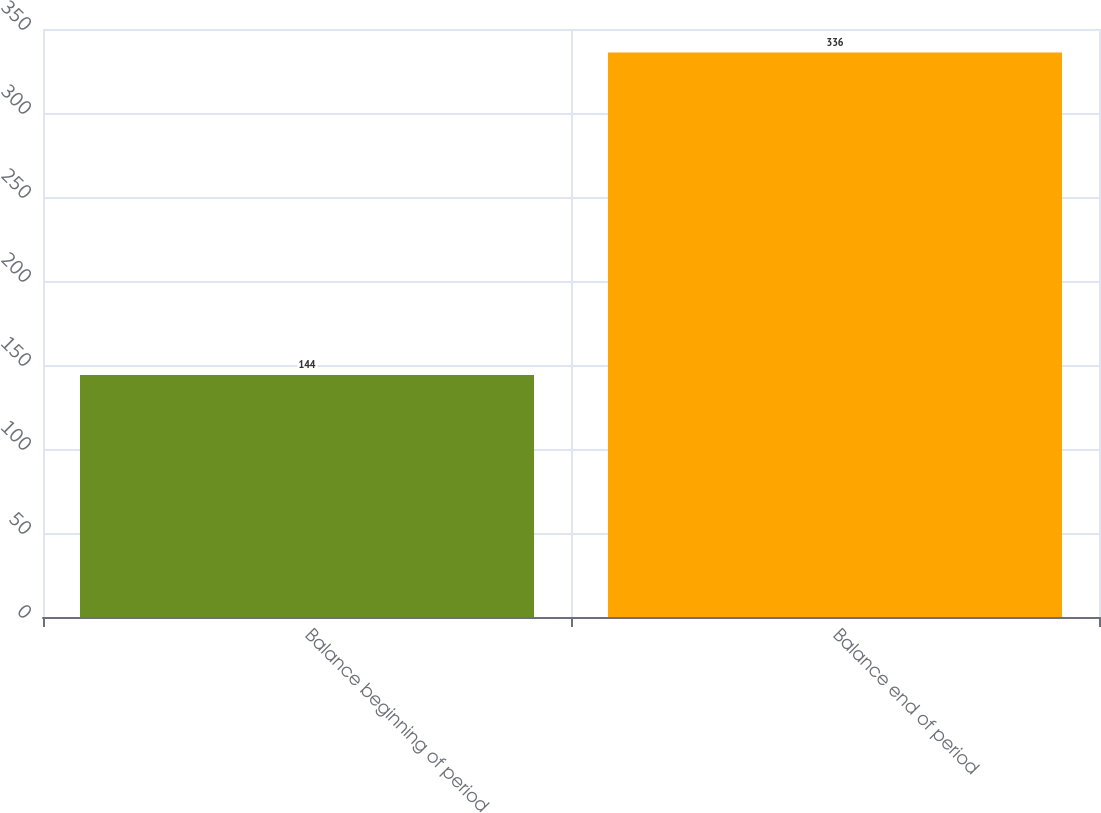<chart> <loc_0><loc_0><loc_500><loc_500><bar_chart><fcel>Balance beginning of period<fcel>Balance end of period<nl><fcel>144<fcel>336<nl></chart> 